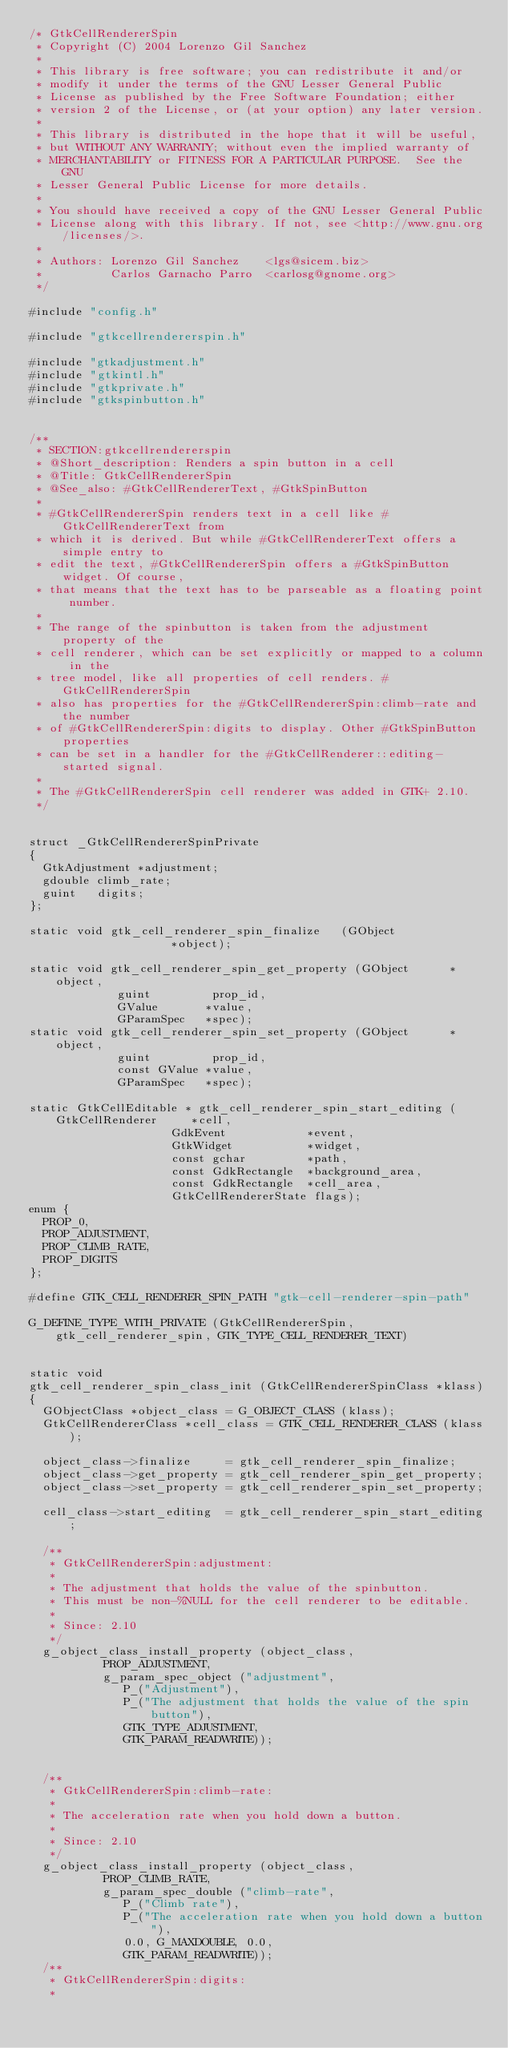Convert code to text. <code><loc_0><loc_0><loc_500><loc_500><_C_>/* GtkCellRendererSpin
 * Copyright (C) 2004 Lorenzo Gil Sanchez
 *
 * This library is free software; you can redistribute it and/or
 * modify it under the terms of the GNU Lesser General Public
 * License as published by the Free Software Foundation; either
 * version 2 of the License, or (at your option) any later version.
 *
 * This library is distributed in the hope that it will be useful,
 * but WITHOUT ANY WARRANTY; without even the implied warranty of
 * MERCHANTABILITY or FITNESS FOR A PARTICULAR PURPOSE.  See the GNU
 * Lesser General Public License for more details.
 *
 * You should have received a copy of the GNU Lesser General Public
 * License along with this library. If not, see <http://www.gnu.org/licenses/>.
 *
 * Authors: Lorenzo Gil Sanchez    <lgs@sicem.biz>
 *          Carlos Garnacho Parro  <carlosg@gnome.org>
 */

#include "config.h"

#include "gtkcellrendererspin.h"

#include "gtkadjustment.h"
#include "gtkintl.h"
#include "gtkprivate.h"
#include "gtkspinbutton.h"


/**
 * SECTION:gtkcellrendererspin
 * @Short_description: Renders a spin button in a cell
 * @Title: GtkCellRendererSpin
 * @See_also: #GtkCellRendererText, #GtkSpinButton
 *
 * #GtkCellRendererSpin renders text in a cell like #GtkCellRendererText from
 * which it is derived. But while #GtkCellRendererText offers a simple entry to
 * edit the text, #GtkCellRendererSpin offers a #GtkSpinButton widget. Of course,
 * that means that the text has to be parseable as a floating point number.
 *
 * The range of the spinbutton is taken from the adjustment property of the
 * cell renderer, which can be set explicitly or mapped to a column in the
 * tree model, like all properties of cell renders. #GtkCellRendererSpin
 * also has properties for the #GtkCellRendererSpin:climb-rate and the number
 * of #GtkCellRendererSpin:digits to display. Other #GtkSpinButton properties
 * can be set in a handler for the #GtkCellRenderer::editing-started signal.
 *
 * The #GtkCellRendererSpin cell renderer was added in GTK+ 2.10.
 */


struct _GtkCellRendererSpinPrivate
{
  GtkAdjustment *adjustment;
  gdouble climb_rate;
  guint   digits;
};

static void gtk_cell_renderer_spin_finalize   (GObject                  *object);

static void gtk_cell_renderer_spin_get_property (GObject      *object,
						 guint         prop_id,
						 GValue       *value,
						 GParamSpec   *spec);
static void gtk_cell_renderer_spin_set_property (GObject      *object,
						 guint         prop_id,
						 const GValue *value,
						 GParamSpec   *spec);

static GtkCellEditable * gtk_cell_renderer_spin_start_editing (GtkCellRenderer     *cell,
							       GdkEvent            *event,
							       GtkWidget           *widget,
							       const gchar         *path,
							       const GdkRectangle  *background_area,
							       const GdkRectangle  *cell_area,
							       GtkCellRendererState flags);
enum {
  PROP_0,
  PROP_ADJUSTMENT,
  PROP_CLIMB_RATE,
  PROP_DIGITS
};

#define GTK_CELL_RENDERER_SPIN_PATH "gtk-cell-renderer-spin-path"

G_DEFINE_TYPE_WITH_PRIVATE (GtkCellRendererSpin, gtk_cell_renderer_spin, GTK_TYPE_CELL_RENDERER_TEXT)


static void
gtk_cell_renderer_spin_class_init (GtkCellRendererSpinClass *klass)
{
  GObjectClass *object_class = G_OBJECT_CLASS (klass);
  GtkCellRendererClass *cell_class = GTK_CELL_RENDERER_CLASS (klass);

  object_class->finalize     = gtk_cell_renderer_spin_finalize;
  object_class->get_property = gtk_cell_renderer_spin_get_property;
  object_class->set_property = gtk_cell_renderer_spin_set_property;

  cell_class->start_editing  = gtk_cell_renderer_spin_start_editing;

  /**
   * GtkCellRendererSpin:adjustment:
   *
   * The adjustment that holds the value of the spinbutton. 
   * This must be non-%NULL for the cell renderer to be editable.
   *
   * Since: 2.10
   */
  g_object_class_install_property (object_class,
				   PROP_ADJUSTMENT,
				   g_param_spec_object ("adjustment",
							P_("Adjustment"),
							P_("The adjustment that holds the value of the spin button"),
							GTK_TYPE_ADJUSTMENT,
							GTK_PARAM_READWRITE));


  /**
   * GtkCellRendererSpin:climb-rate:
   *
   * The acceleration rate when you hold down a button.
   *
   * Since: 2.10
   */
  g_object_class_install_property (object_class,
				   PROP_CLIMB_RATE,
				   g_param_spec_double ("climb-rate",
							P_("Climb rate"),
							P_("The acceleration rate when you hold down a button"),
							0.0, G_MAXDOUBLE, 0.0,
							GTK_PARAM_READWRITE));  
  /**
   * GtkCellRendererSpin:digits:
   *</code> 